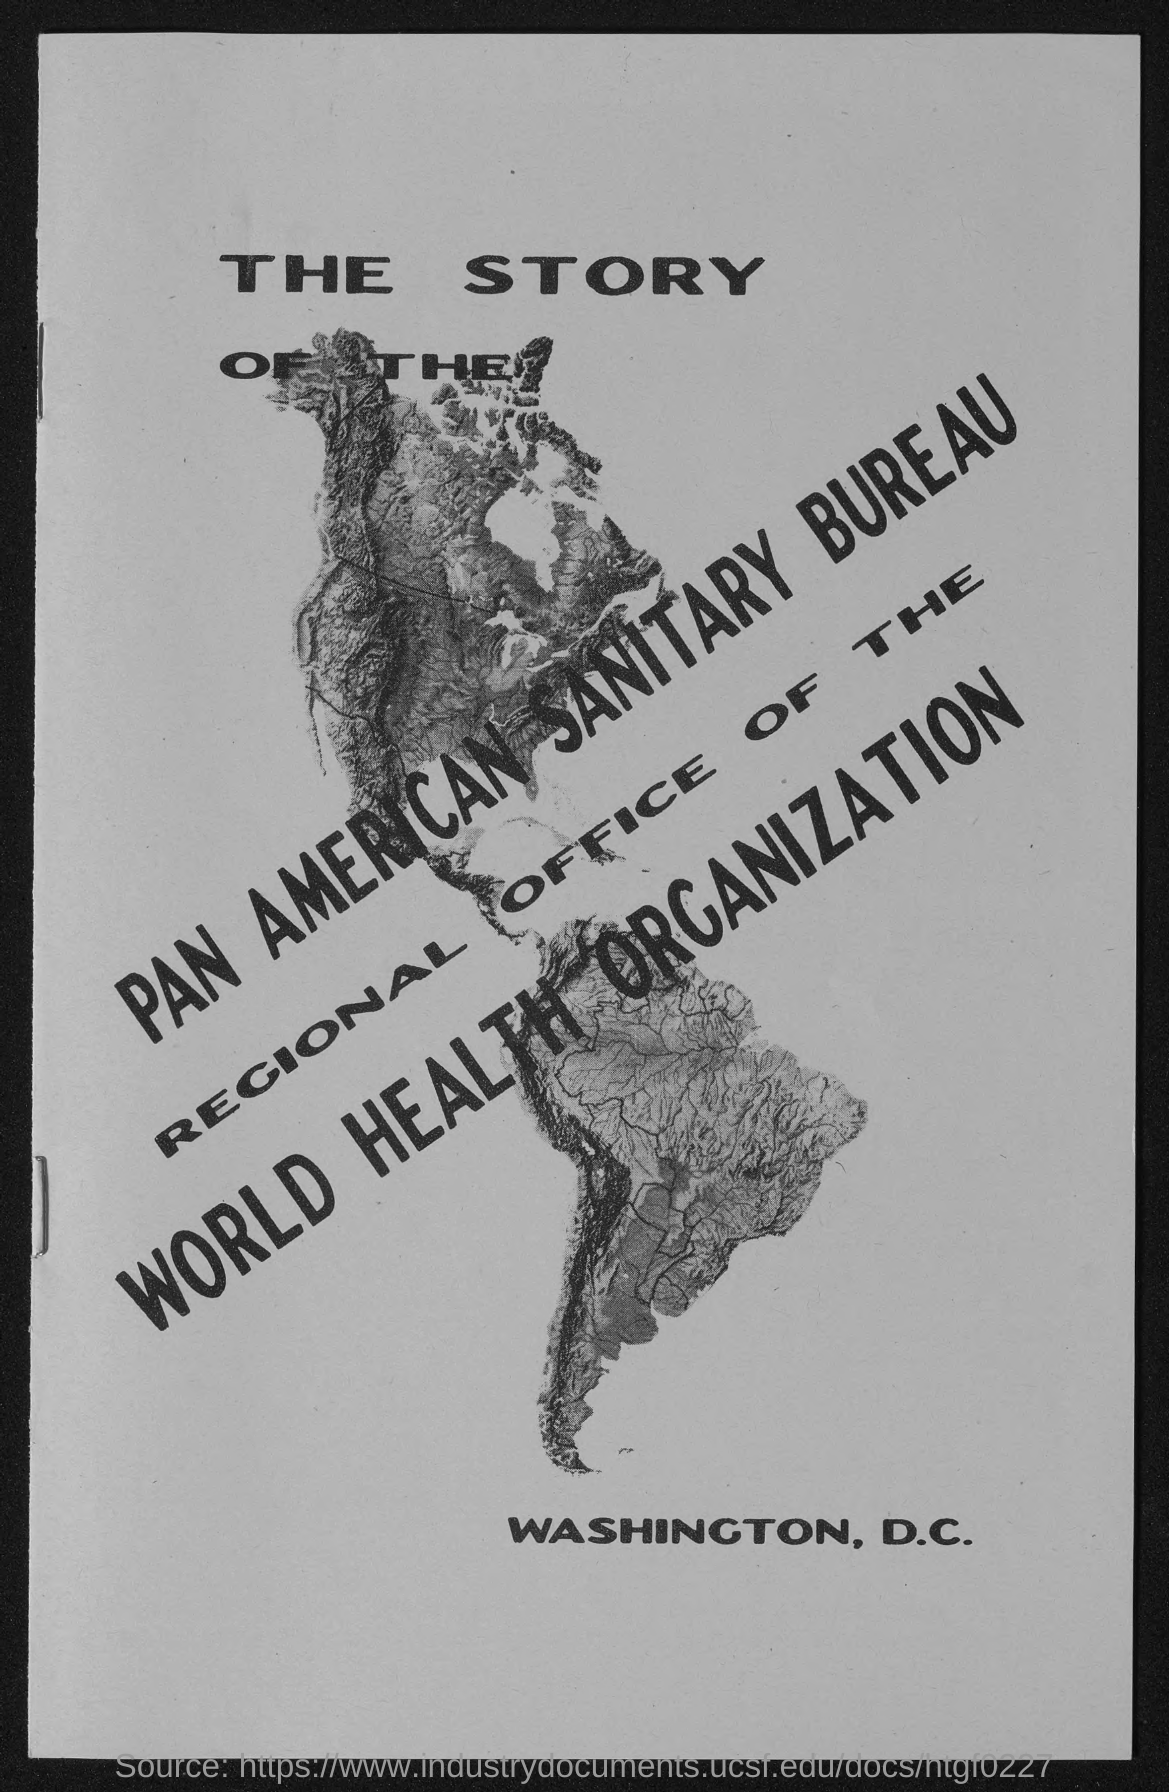Which bureau is mentioned?
Your answer should be very brief. PAN AMERICAN SANITARY BUREAU. Which place is mentioned?
Your answer should be compact. WASHINGTON, D.C. 